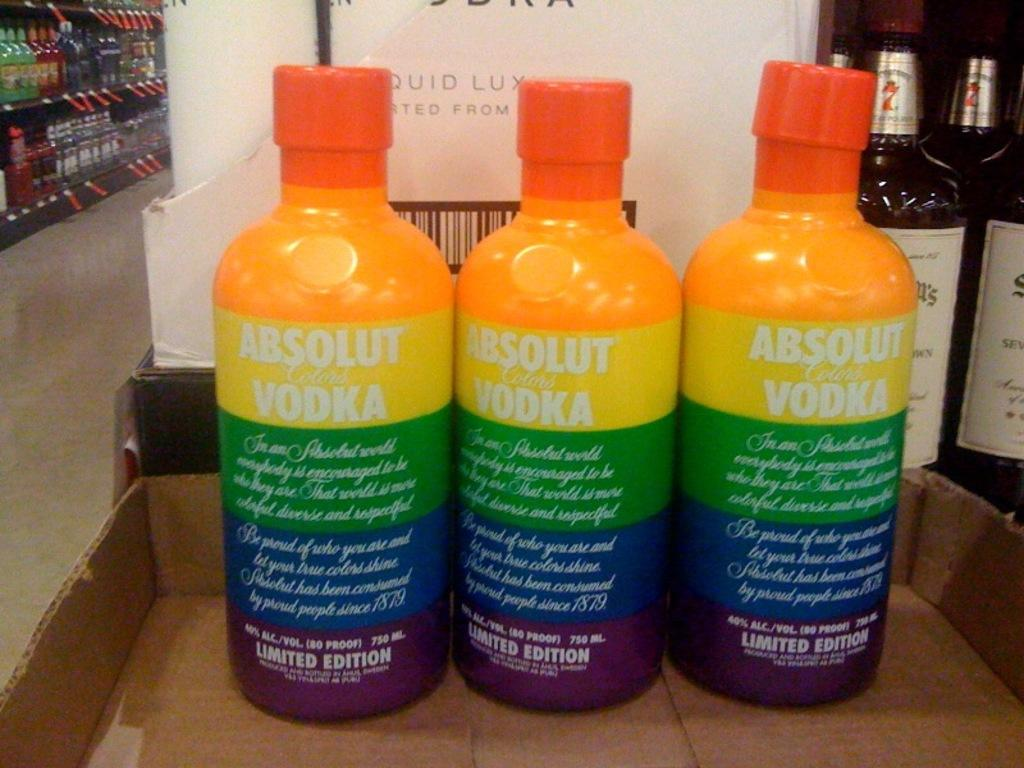<image>
Describe the image concisely. Three very colorful bottles of Absolut Vodka sitting on top of a box. 